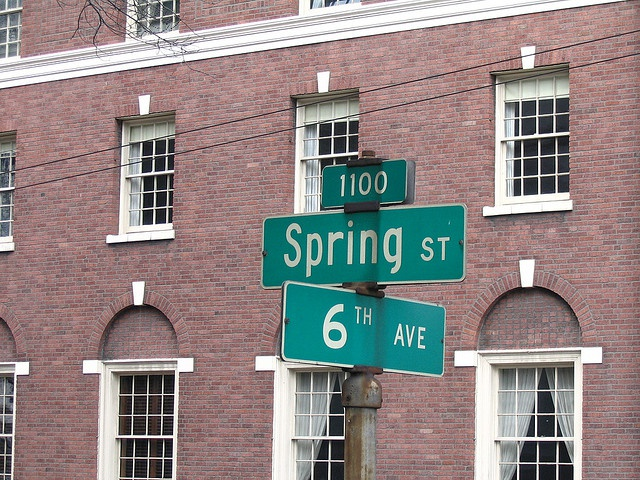Describe the objects in this image and their specific colors. I can see various objects in this image with different colors. 